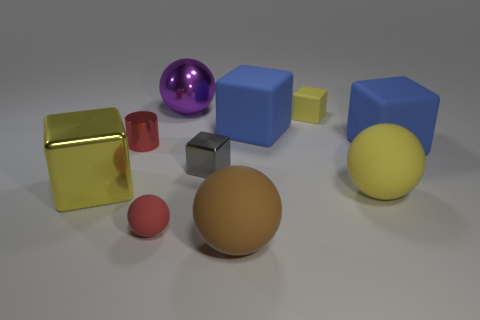Subtract all yellow rubber balls. How many balls are left? 3 Subtract 1 spheres. How many spheres are left? 3 Subtract all yellow spheres. How many spheres are left? 3 Subtract all red balls. Subtract all blue cubes. How many balls are left? 3 Subtract all cylinders. How many objects are left? 9 Add 8 yellow cubes. How many yellow cubes exist? 10 Subtract 0 green cylinders. How many objects are left? 10 Subtract all tiny purple metallic cylinders. Subtract all rubber spheres. How many objects are left? 7 Add 5 metallic cubes. How many metallic cubes are left? 7 